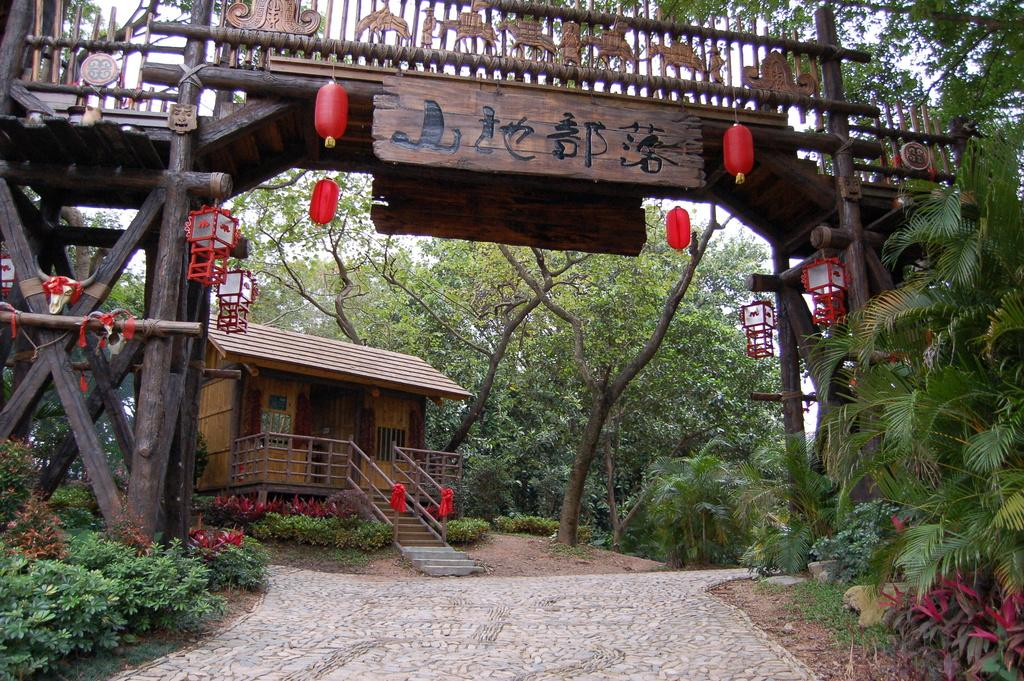What type of house is shown in the image? There is a wooden house in the image. What can be seen around the house? There is a lot of greenery around the house. How can someone enter the house? There is an entrance in front of the house. What is special about the entrance? The entrance is decorated with red lights. Can you see a sock hanging from the roof of the house in the image? No, there is no sock visible in the image. 